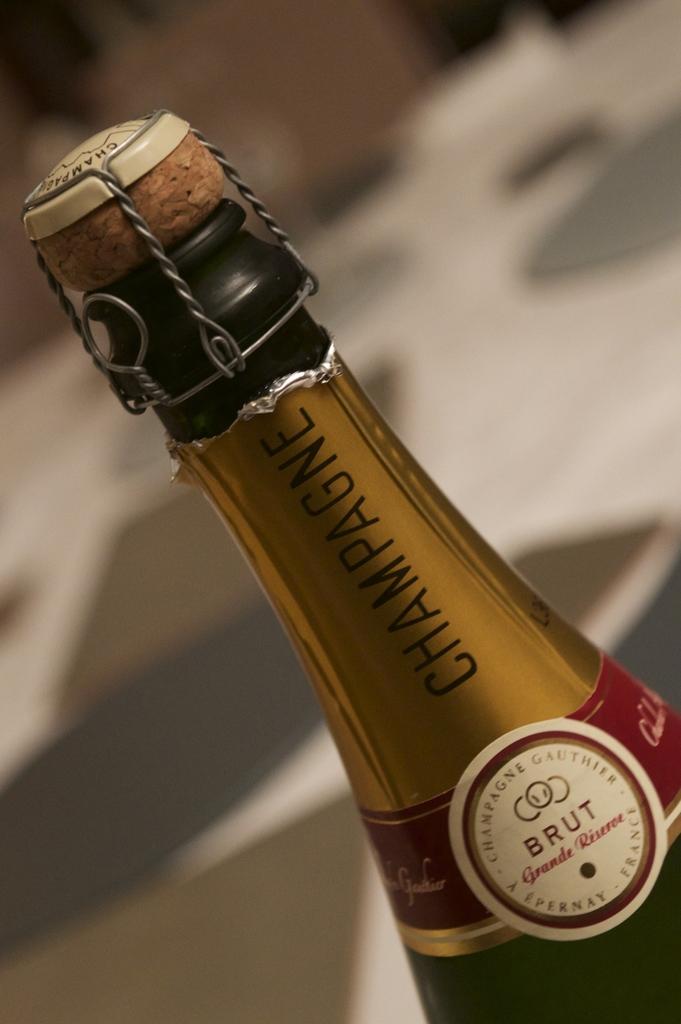What is in the bottle?
Provide a succinct answer. Champagne. 